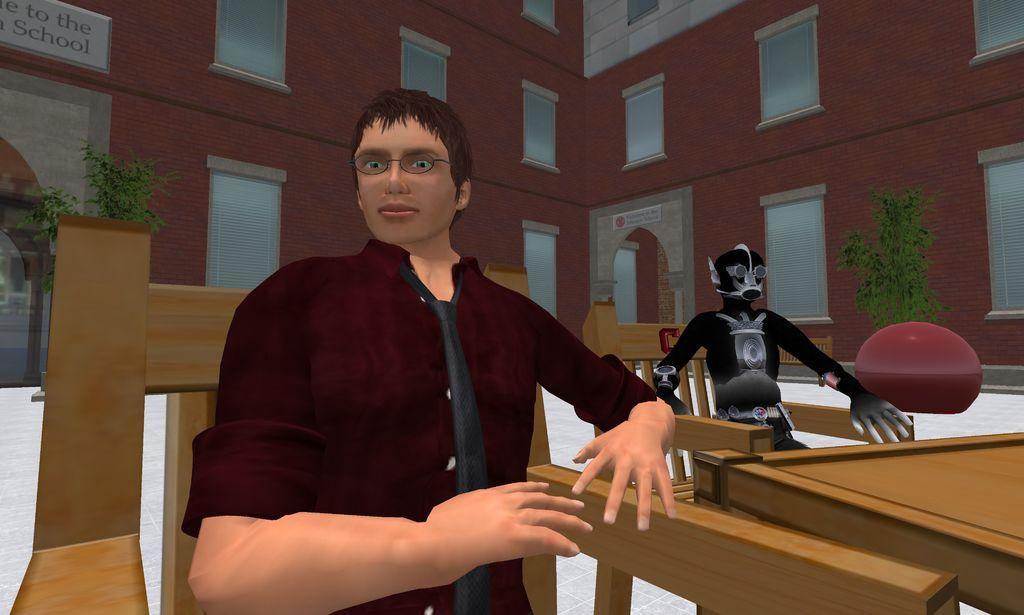Can you describe this image briefly? In this image we can see a person sitting in a chair beside a table. We can also see a robot placed in a chair, some plants and a building with windows and a signboard. 